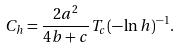<formula> <loc_0><loc_0><loc_500><loc_500>C _ { h } = \frac { 2 a ^ { 2 } } { 4 b + c } T _ { c } ( - \ln h ) ^ { - 1 } .</formula> 